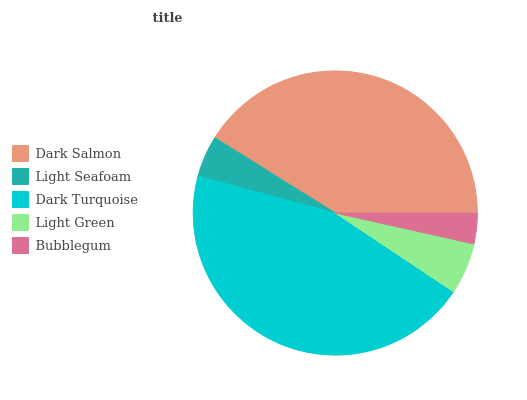Is Bubblegum the minimum?
Answer yes or no. Yes. Is Dark Turquoise the maximum?
Answer yes or no. Yes. Is Light Seafoam the minimum?
Answer yes or no. No. Is Light Seafoam the maximum?
Answer yes or no. No. Is Dark Salmon greater than Light Seafoam?
Answer yes or no. Yes. Is Light Seafoam less than Dark Salmon?
Answer yes or no. Yes. Is Light Seafoam greater than Dark Salmon?
Answer yes or no. No. Is Dark Salmon less than Light Seafoam?
Answer yes or no. No. Is Light Green the high median?
Answer yes or no. Yes. Is Light Green the low median?
Answer yes or no. Yes. Is Light Seafoam the high median?
Answer yes or no. No. Is Dark Salmon the low median?
Answer yes or no. No. 